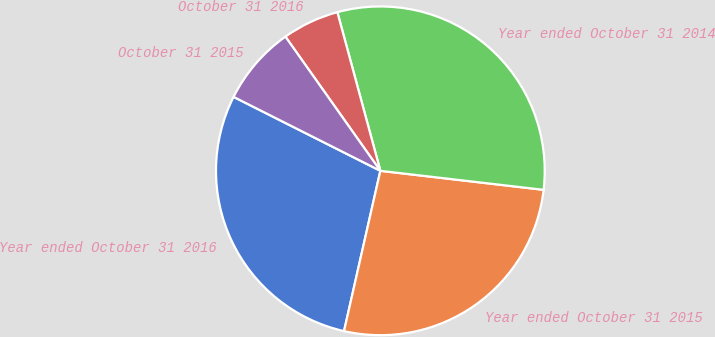Convert chart. <chart><loc_0><loc_0><loc_500><loc_500><pie_chart><fcel>Year ended October 31 2016<fcel>Year ended October 31 2015<fcel>Year ended October 31 2014<fcel>October 31 2016<fcel>October 31 2015<nl><fcel>28.88%<fcel>26.7%<fcel>31.06%<fcel>5.59%<fcel>7.77%<nl></chart> 